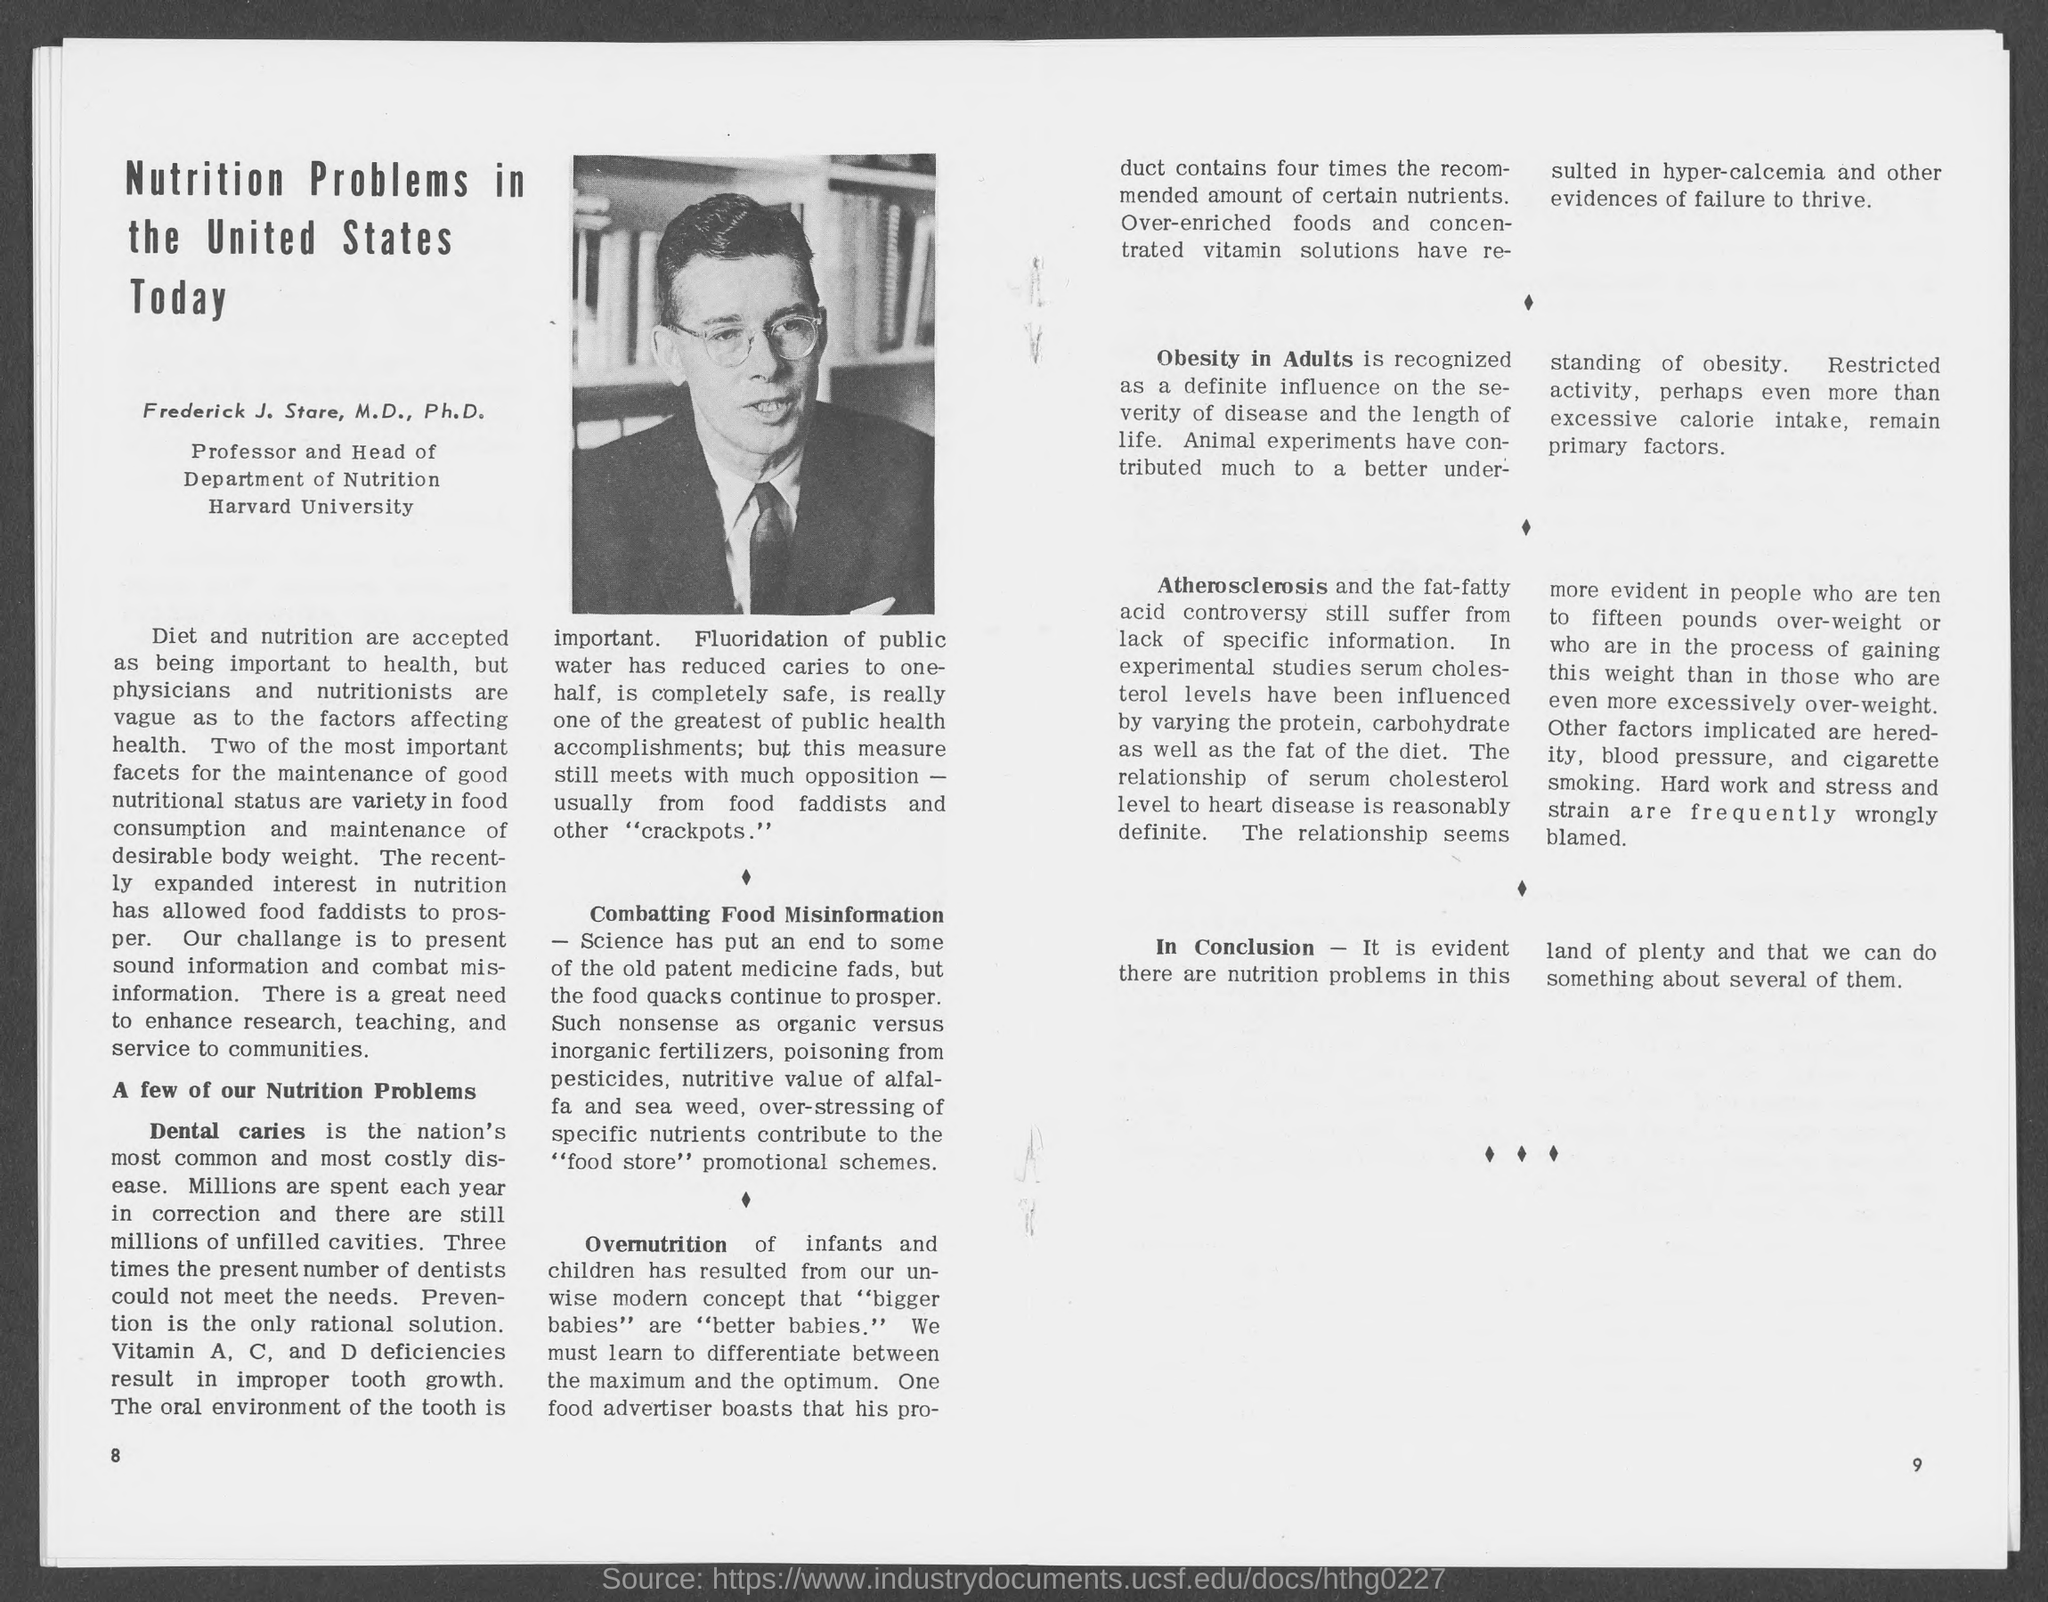List a handful of essential elements in this visual. The number at the bottom right page is 9. The number at the bottom left page is 8. 